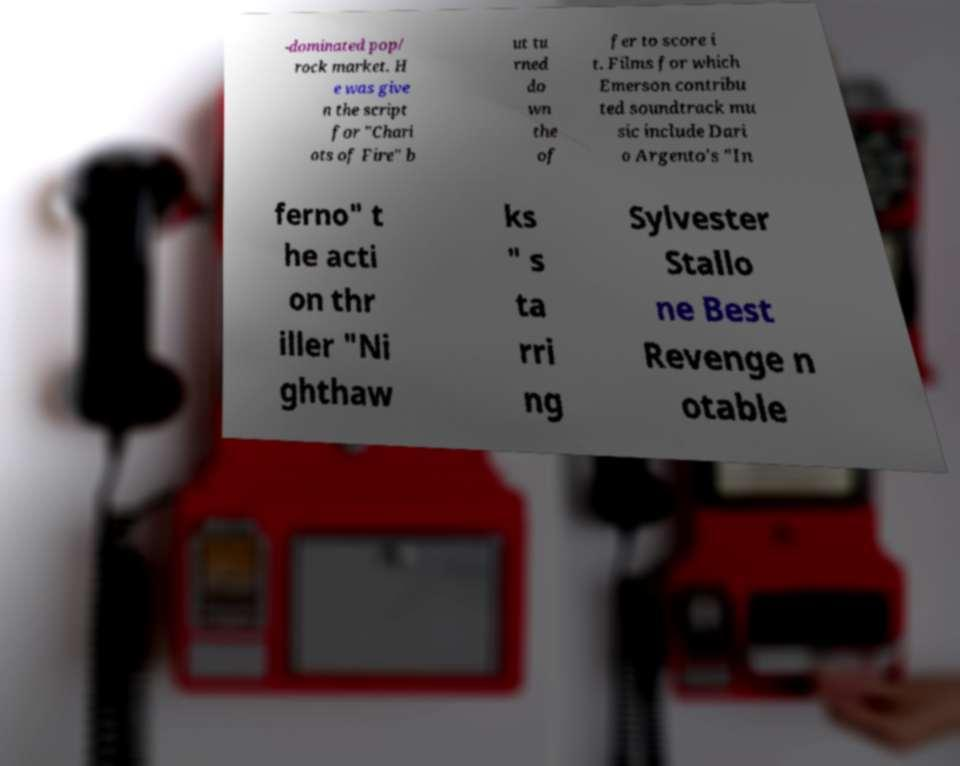Can you read and provide the text displayed in the image?This photo seems to have some interesting text. Can you extract and type it out for me? -dominated pop/ rock market. H e was give n the script for "Chari ots of Fire" b ut tu rned do wn the of fer to score i t. Films for which Emerson contribu ted soundtrack mu sic include Dari o Argento's "In ferno" t he acti on thr iller "Ni ghthaw ks " s ta rri ng Sylvester Stallo ne Best Revenge n otable 